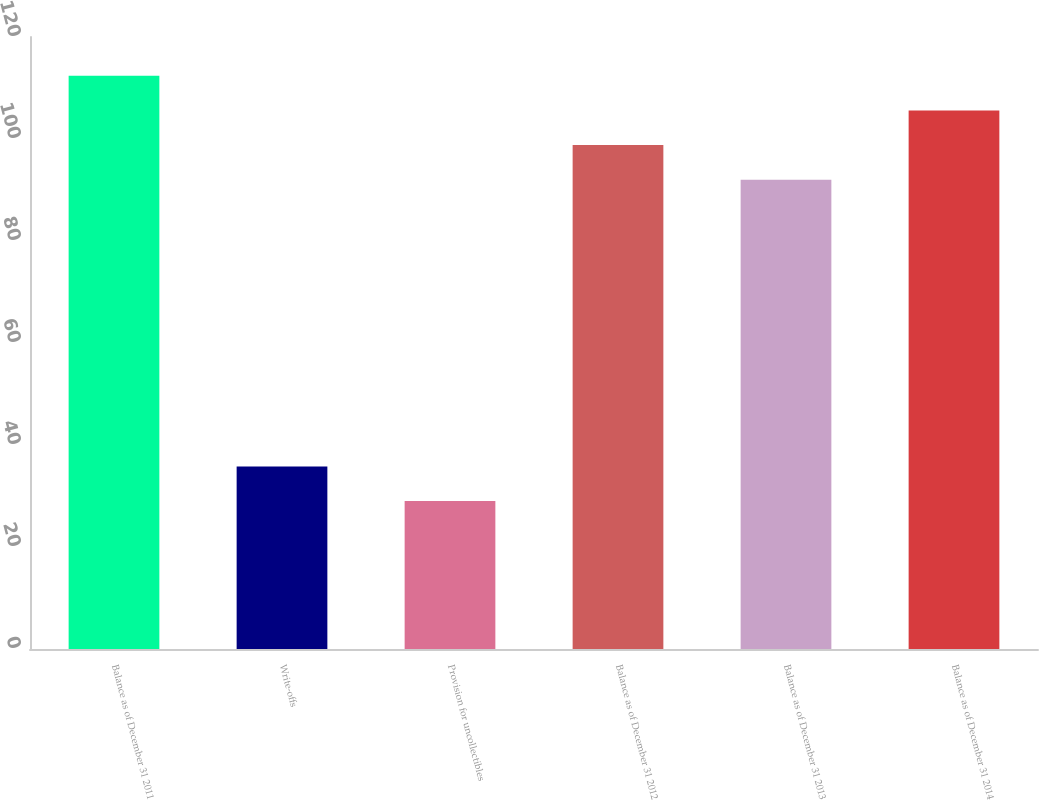Convert chart to OTSL. <chart><loc_0><loc_0><loc_500><loc_500><bar_chart><fcel>Balance as of December 31 2011<fcel>Write-offs<fcel>Provision for uncollectibles<fcel>Balance as of December 31 2012<fcel>Balance as of December 31 2013<fcel>Balance as of December 31 2014<nl><fcel>112.4<fcel>35.8<fcel>29<fcel>98.8<fcel>92<fcel>105.6<nl></chart> 